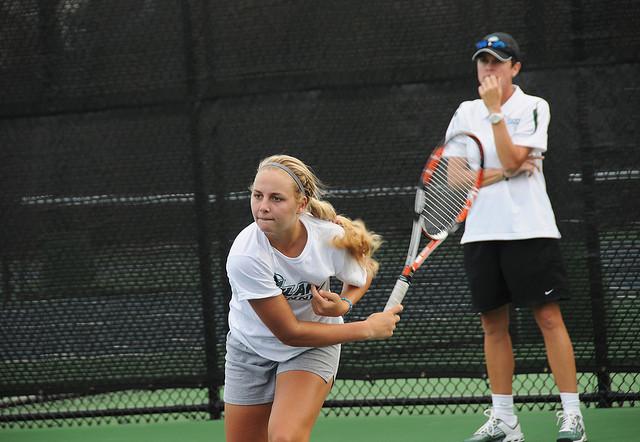What is the black fence made of?
Concise answer only. Wire. How many people are wearing long pants?
Answer briefly. 0. Does this person have on a hat?
Write a very short answer. Yes. Is the man playing tennis?
Keep it brief. No. What color is the man's hat?
Short answer required. Black. What does her shirt tell you you've met?
Quick response, please. Match. 